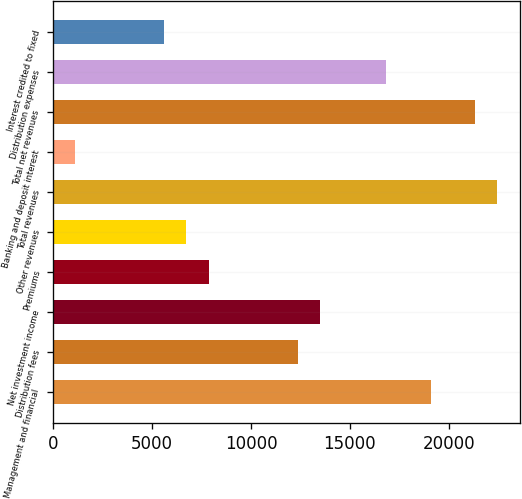Convert chart. <chart><loc_0><loc_0><loc_500><loc_500><bar_chart><fcel>Management and financial<fcel>Distribution fees<fcel>Net investment income<fcel>Premiums<fcel>Other revenues<fcel>Total revenues<fcel>Banking and deposit interest<fcel>Total net revenues<fcel>Distribution expenses<fcel>Interest credited to fixed<nl><fcel>19088.9<fcel>12352.7<fcel>13475.4<fcel>7861.9<fcel>6739.2<fcel>22457<fcel>1125.7<fcel>21334.3<fcel>16843.5<fcel>5616.5<nl></chart> 